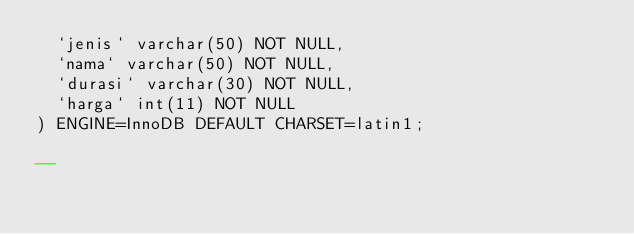<code> <loc_0><loc_0><loc_500><loc_500><_SQL_>  `jenis` varchar(50) NOT NULL,
  `nama` varchar(50) NOT NULL,
  `durasi` varchar(30) NOT NULL,
  `harga` int(11) NOT NULL
) ENGINE=InnoDB DEFAULT CHARSET=latin1;

--</code> 